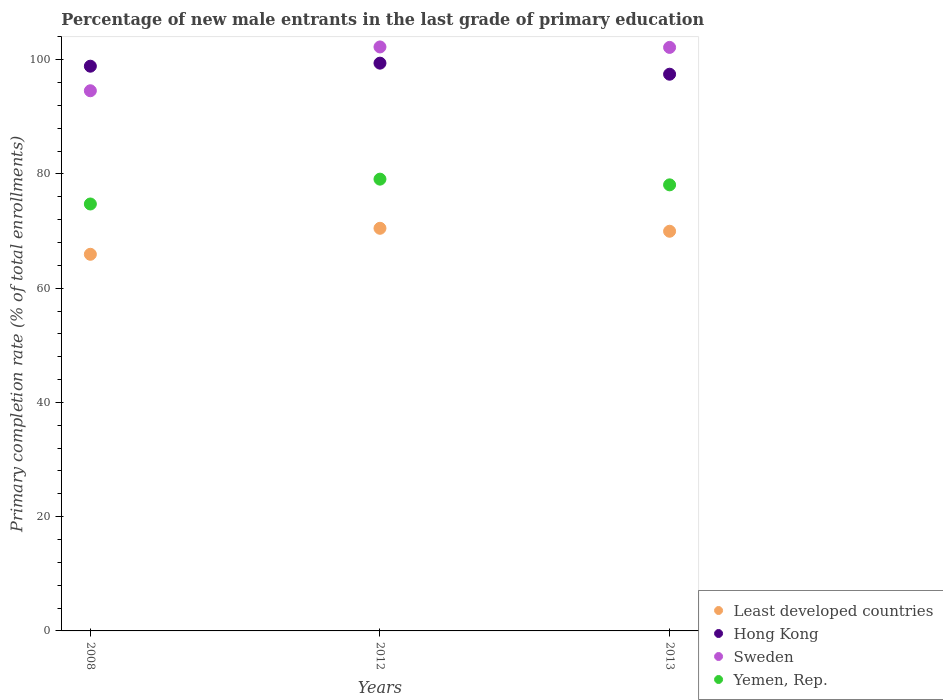Is the number of dotlines equal to the number of legend labels?
Keep it short and to the point. Yes. What is the percentage of new male entrants in Hong Kong in 2008?
Offer a terse response. 98.86. Across all years, what is the maximum percentage of new male entrants in Yemen, Rep.?
Provide a short and direct response. 79.08. Across all years, what is the minimum percentage of new male entrants in Least developed countries?
Your response must be concise. 65.93. In which year was the percentage of new male entrants in Hong Kong maximum?
Offer a very short reply. 2012. What is the total percentage of new male entrants in Hong Kong in the graph?
Your answer should be very brief. 295.7. What is the difference between the percentage of new male entrants in Sweden in 2008 and that in 2012?
Keep it short and to the point. -7.67. What is the difference between the percentage of new male entrants in Yemen, Rep. in 2013 and the percentage of new male entrants in Least developed countries in 2008?
Your response must be concise. 12.16. What is the average percentage of new male entrants in Hong Kong per year?
Ensure brevity in your answer.  98.57. In the year 2013, what is the difference between the percentage of new male entrants in Sweden and percentage of new male entrants in Least developed countries?
Ensure brevity in your answer.  32.18. What is the ratio of the percentage of new male entrants in Least developed countries in 2008 to that in 2012?
Your answer should be compact. 0.94. What is the difference between the highest and the second highest percentage of new male entrants in Least developed countries?
Your answer should be compact. 0.52. What is the difference between the highest and the lowest percentage of new male entrants in Hong Kong?
Offer a terse response. 1.94. Is the sum of the percentage of new male entrants in Least developed countries in 2008 and 2013 greater than the maximum percentage of new male entrants in Sweden across all years?
Provide a succinct answer. Yes. Is the percentage of new male entrants in Least developed countries strictly less than the percentage of new male entrants in Yemen, Rep. over the years?
Ensure brevity in your answer.  Yes. How many years are there in the graph?
Give a very brief answer. 3. What is the difference between two consecutive major ticks on the Y-axis?
Offer a terse response. 20. Are the values on the major ticks of Y-axis written in scientific E-notation?
Offer a very short reply. No. Does the graph contain any zero values?
Make the answer very short. No. How many legend labels are there?
Your response must be concise. 4. What is the title of the graph?
Ensure brevity in your answer.  Percentage of new male entrants in the last grade of primary education. What is the label or title of the X-axis?
Give a very brief answer. Years. What is the label or title of the Y-axis?
Provide a succinct answer. Primary completion rate (% of total enrollments). What is the Primary completion rate (% of total enrollments) in Least developed countries in 2008?
Offer a terse response. 65.93. What is the Primary completion rate (% of total enrollments) in Hong Kong in 2008?
Offer a very short reply. 98.86. What is the Primary completion rate (% of total enrollments) in Sweden in 2008?
Your answer should be compact. 94.56. What is the Primary completion rate (% of total enrollments) of Yemen, Rep. in 2008?
Offer a terse response. 74.74. What is the Primary completion rate (% of total enrollments) in Least developed countries in 2012?
Make the answer very short. 70.48. What is the Primary completion rate (% of total enrollments) of Hong Kong in 2012?
Provide a short and direct response. 99.39. What is the Primary completion rate (% of total enrollments) in Sweden in 2012?
Keep it short and to the point. 102.23. What is the Primary completion rate (% of total enrollments) of Yemen, Rep. in 2012?
Your response must be concise. 79.08. What is the Primary completion rate (% of total enrollments) in Least developed countries in 2013?
Give a very brief answer. 69.96. What is the Primary completion rate (% of total enrollments) of Hong Kong in 2013?
Your answer should be very brief. 97.45. What is the Primary completion rate (% of total enrollments) in Sweden in 2013?
Ensure brevity in your answer.  102.15. What is the Primary completion rate (% of total enrollments) of Yemen, Rep. in 2013?
Provide a short and direct response. 78.09. Across all years, what is the maximum Primary completion rate (% of total enrollments) in Least developed countries?
Your answer should be compact. 70.48. Across all years, what is the maximum Primary completion rate (% of total enrollments) of Hong Kong?
Offer a terse response. 99.39. Across all years, what is the maximum Primary completion rate (% of total enrollments) in Sweden?
Your response must be concise. 102.23. Across all years, what is the maximum Primary completion rate (% of total enrollments) of Yemen, Rep.?
Make the answer very short. 79.08. Across all years, what is the minimum Primary completion rate (% of total enrollments) in Least developed countries?
Provide a short and direct response. 65.93. Across all years, what is the minimum Primary completion rate (% of total enrollments) of Hong Kong?
Offer a very short reply. 97.45. Across all years, what is the minimum Primary completion rate (% of total enrollments) in Sweden?
Ensure brevity in your answer.  94.56. Across all years, what is the minimum Primary completion rate (% of total enrollments) in Yemen, Rep.?
Give a very brief answer. 74.74. What is the total Primary completion rate (% of total enrollments) of Least developed countries in the graph?
Offer a terse response. 206.38. What is the total Primary completion rate (% of total enrollments) in Hong Kong in the graph?
Give a very brief answer. 295.7. What is the total Primary completion rate (% of total enrollments) in Sweden in the graph?
Ensure brevity in your answer.  298.93. What is the total Primary completion rate (% of total enrollments) of Yemen, Rep. in the graph?
Ensure brevity in your answer.  231.9. What is the difference between the Primary completion rate (% of total enrollments) in Least developed countries in 2008 and that in 2012?
Offer a very short reply. -4.55. What is the difference between the Primary completion rate (% of total enrollments) in Hong Kong in 2008 and that in 2012?
Give a very brief answer. -0.53. What is the difference between the Primary completion rate (% of total enrollments) of Sweden in 2008 and that in 2012?
Your answer should be compact. -7.67. What is the difference between the Primary completion rate (% of total enrollments) of Yemen, Rep. in 2008 and that in 2012?
Make the answer very short. -4.35. What is the difference between the Primary completion rate (% of total enrollments) of Least developed countries in 2008 and that in 2013?
Keep it short and to the point. -4.03. What is the difference between the Primary completion rate (% of total enrollments) in Hong Kong in 2008 and that in 2013?
Provide a short and direct response. 1.4. What is the difference between the Primary completion rate (% of total enrollments) in Sweden in 2008 and that in 2013?
Offer a very short reply. -7.59. What is the difference between the Primary completion rate (% of total enrollments) of Yemen, Rep. in 2008 and that in 2013?
Give a very brief answer. -3.35. What is the difference between the Primary completion rate (% of total enrollments) of Least developed countries in 2012 and that in 2013?
Ensure brevity in your answer.  0.52. What is the difference between the Primary completion rate (% of total enrollments) in Hong Kong in 2012 and that in 2013?
Offer a very short reply. 1.94. What is the difference between the Primary completion rate (% of total enrollments) of Sweden in 2012 and that in 2013?
Your answer should be very brief. 0.08. What is the difference between the Primary completion rate (% of total enrollments) of Yemen, Rep. in 2012 and that in 2013?
Your answer should be compact. 1. What is the difference between the Primary completion rate (% of total enrollments) of Least developed countries in 2008 and the Primary completion rate (% of total enrollments) of Hong Kong in 2012?
Your response must be concise. -33.46. What is the difference between the Primary completion rate (% of total enrollments) of Least developed countries in 2008 and the Primary completion rate (% of total enrollments) of Sweden in 2012?
Make the answer very short. -36.3. What is the difference between the Primary completion rate (% of total enrollments) of Least developed countries in 2008 and the Primary completion rate (% of total enrollments) of Yemen, Rep. in 2012?
Your answer should be compact. -13.15. What is the difference between the Primary completion rate (% of total enrollments) in Hong Kong in 2008 and the Primary completion rate (% of total enrollments) in Sweden in 2012?
Ensure brevity in your answer.  -3.37. What is the difference between the Primary completion rate (% of total enrollments) of Hong Kong in 2008 and the Primary completion rate (% of total enrollments) of Yemen, Rep. in 2012?
Your answer should be compact. 19.77. What is the difference between the Primary completion rate (% of total enrollments) of Sweden in 2008 and the Primary completion rate (% of total enrollments) of Yemen, Rep. in 2012?
Provide a succinct answer. 15.47. What is the difference between the Primary completion rate (% of total enrollments) of Least developed countries in 2008 and the Primary completion rate (% of total enrollments) of Hong Kong in 2013?
Your answer should be compact. -31.52. What is the difference between the Primary completion rate (% of total enrollments) in Least developed countries in 2008 and the Primary completion rate (% of total enrollments) in Sweden in 2013?
Offer a very short reply. -36.22. What is the difference between the Primary completion rate (% of total enrollments) in Least developed countries in 2008 and the Primary completion rate (% of total enrollments) in Yemen, Rep. in 2013?
Give a very brief answer. -12.16. What is the difference between the Primary completion rate (% of total enrollments) in Hong Kong in 2008 and the Primary completion rate (% of total enrollments) in Sweden in 2013?
Offer a terse response. -3.29. What is the difference between the Primary completion rate (% of total enrollments) of Hong Kong in 2008 and the Primary completion rate (% of total enrollments) of Yemen, Rep. in 2013?
Your answer should be compact. 20.77. What is the difference between the Primary completion rate (% of total enrollments) in Sweden in 2008 and the Primary completion rate (% of total enrollments) in Yemen, Rep. in 2013?
Provide a succinct answer. 16.47. What is the difference between the Primary completion rate (% of total enrollments) in Least developed countries in 2012 and the Primary completion rate (% of total enrollments) in Hong Kong in 2013?
Provide a succinct answer. -26.97. What is the difference between the Primary completion rate (% of total enrollments) in Least developed countries in 2012 and the Primary completion rate (% of total enrollments) in Sweden in 2013?
Your answer should be compact. -31.66. What is the difference between the Primary completion rate (% of total enrollments) in Least developed countries in 2012 and the Primary completion rate (% of total enrollments) in Yemen, Rep. in 2013?
Provide a short and direct response. -7.6. What is the difference between the Primary completion rate (% of total enrollments) in Hong Kong in 2012 and the Primary completion rate (% of total enrollments) in Sweden in 2013?
Your answer should be very brief. -2.76. What is the difference between the Primary completion rate (% of total enrollments) in Hong Kong in 2012 and the Primary completion rate (% of total enrollments) in Yemen, Rep. in 2013?
Your answer should be very brief. 21.3. What is the difference between the Primary completion rate (% of total enrollments) in Sweden in 2012 and the Primary completion rate (% of total enrollments) in Yemen, Rep. in 2013?
Your answer should be compact. 24.14. What is the average Primary completion rate (% of total enrollments) in Least developed countries per year?
Your answer should be compact. 68.79. What is the average Primary completion rate (% of total enrollments) in Hong Kong per year?
Offer a very short reply. 98.57. What is the average Primary completion rate (% of total enrollments) in Sweden per year?
Offer a very short reply. 99.64. What is the average Primary completion rate (% of total enrollments) of Yemen, Rep. per year?
Offer a terse response. 77.3. In the year 2008, what is the difference between the Primary completion rate (% of total enrollments) of Least developed countries and Primary completion rate (% of total enrollments) of Hong Kong?
Your answer should be very brief. -32.93. In the year 2008, what is the difference between the Primary completion rate (% of total enrollments) in Least developed countries and Primary completion rate (% of total enrollments) in Sweden?
Ensure brevity in your answer.  -28.63. In the year 2008, what is the difference between the Primary completion rate (% of total enrollments) of Least developed countries and Primary completion rate (% of total enrollments) of Yemen, Rep.?
Your answer should be very brief. -8.81. In the year 2008, what is the difference between the Primary completion rate (% of total enrollments) of Hong Kong and Primary completion rate (% of total enrollments) of Yemen, Rep.?
Offer a terse response. 24.12. In the year 2008, what is the difference between the Primary completion rate (% of total enrollments) in Sweden and Primary completion rate (% of total enrollments) in Yemen, Rep.?
Give a very brief answer. 19.82. In the year 2012, what is the difference between the Primary completion rate (% of total enrollments) in Least developed countries and Primary completion rate (% of total enrollments) in Hong Kong?
Provide a succinct answer. -28.91. In the year 2012, what is the difference between the Primary completion rate (% of total enrollments) of Least developed countries and Primary completion rate (% of total enrollments) of Sweden?
Keep it short and to the point. -31.74. In the year 2012, what is the difference between the Primary completion rate (% of total enrollments) in Least developed countries and Primary completion rate (% of total enrollments) in Yemen, Rep.?
Offer a very short reply. -8.6. In the year 2012, what is the difference between the Primary completion rate (% of total enrollments) of Hong Kong and Primary completion rate (% of total enrollments) of Sweden?
Your response must be concise. -2.84. In the year 2012, what is the difference between the Primary completion rate (% of total enrollments) in Hong Kong and Primary completion rate (% of total enrollments) in Yemen, Rep.?
Provide a succinct answer. 20.3. In the year 2012, what is the difference between the Primary completion rate (% of total enrollments) of Sweden and Primary completion rate (% of total enrollments) of Yemen, Rep.?
Your answer should be very brief. 23.14. In the year 2013, what is the difference between the Primary completion rate (% of total enrollments) in Least developed countries and Primary completion rate (% of total enrollments) in Hong Kong?
Offer a very short reply. -27.49. In the year 2013, what is the difference between the Primary completion rate (% of total enrollments) in Least developed countries and Primary completion rate (% of total enrollments) in Sweden?
Provide a succinct answer. -32.18. In the year 2013, what is the difference between the Primary completion rate (% of total enrollments) in Least developed countries and Primary completion rate (% of total enrollments) in Yemen, Rep.?
Make the answer very short. -8.12. In the year 2013, what is the difference between the Primary completion rate (% of total enrollments) of Hong Kong and Primary completion rate (% of total enrollments) of Sweden?
Provide a succinct answer. -4.69. In the year 2013, what is the difference between the Primary completion rate (% of total enrollments) in Hong Kong and Primary completion rate (% of total enrollments) in Yemen, Rep.?
Offer a terse response. 19.37. In the year 2013, what is the difference between the Primary completion rate (% of total enrollments) of Sweden and Primary completion rate (% of total enrollments) of Yemen, Rep.?
Offer a very short reply. 24.06. What is the ratio of the Primary completion rate (% of total enrollments) of Least developed countries in 2008 to that in 2012?
Provide a succinct answer. 0.94. What is the ratio of the Primary completion rate (% of total enrollments) of Sweden in 2008 to that in 2012?
Give a very brief answer. 0.93. What is the ratio of the Primary completion rate (% of total enrollments) of Yemen, Rep. in 2008 to that in 2012?
Provide a succinct answer. 0.94. What is the ratio of the Primary completion rate (% of total enrollments) of Least developed countries in 2008 to that in 2013?
Offer a terse response. 0.94. What is the ratio of the Primary completion rate (% of total enrollments) of Hong Kong in 2008 to that in 2013?
Offer a very short reply. 1.01. What is the ratio of the Primary completion rate (% of total enrollments) in Sweden in 2008 to that in 2013?
Provide a succinct answer. 0.93. What is the ratio of the Primary completion rate (% of total enrollments) of Yemen, Rep. in 2008 to that in 2013?
Make the answer very short. 0.96. What is the ratio of the Primary completion rate (% of total enrollments) in Least developed countries in 2012 to that in 2013?
Ensure brevity in your answer.  1.01. What is the ratio of the Primary completion rate (% of total enrollments) of Hong Kong in 2012 to that in 2013?
Give a very brief answer. 1.02. What is the ratio of the Primary completion rate (% of total enrollments) of Yemen, Rep. in 2012 to that in 2013?
Your answer should be compact. 1.01. What is the difference between the highest and the second highest Primary completion rate (% of total enrollments) of Least developed countries?
Your answer should be compact. 0.52. What is the difference between the highest and the second highest Primary completion rate (% of total enrollments) of Hong Kong?
Your answer should be compact. 0.53. What is the difference between the highest and the second highest Primary completion rate (% of total enrollments) of Sweden?
Make the answer very short. 0.08. What is the difference between the highest and the lowest Primary completion rate (% of total enrollments) of Least developed countries?
Ensure brevity in your answer.  4.55. What is the difference between the highest and the lowest Primary completion rate (% of total enrollments) of Hong Kong?
Offer a terse response. 1.94. What is the difference between the highest and the lowest Primary completion rate (% of total enrollments) in Sweden?
Ensure brevity in your answer.  7.67. What is the difference between the highest and the lowest Primary completion rate (% of total enrollments) of Yemen, Rep.?
Offer a very short reply. 4.35. 